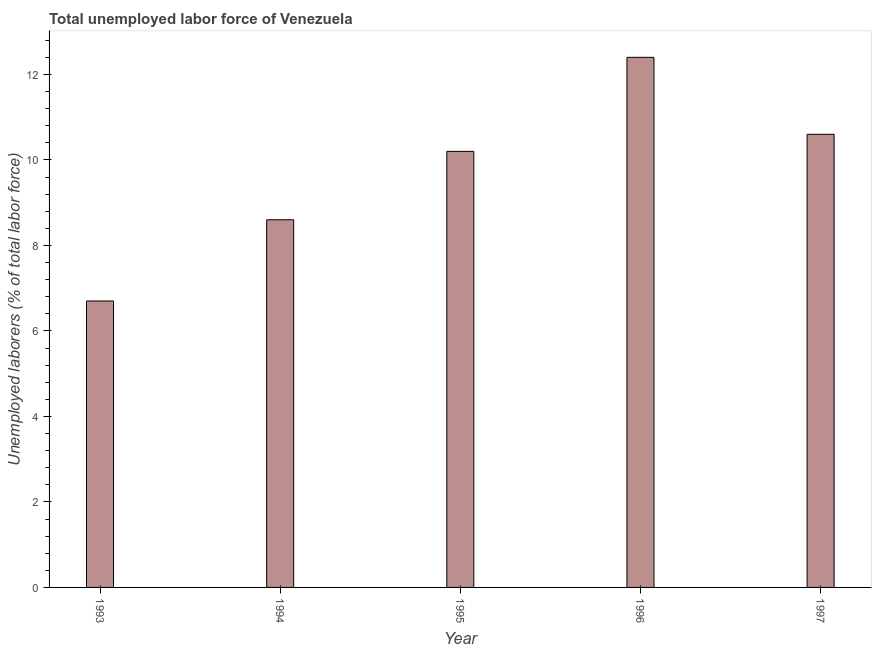What is the title of the graph?
Provide a succinct answer. Total unemployed labor force of Venezuela. What is the label or title of the X-axis?
Ensure brevity in your answer.  Year. What is the label or title of the Y-axis?
Offer a terse response. Unemployed laborers (% of total labor force). What is the total unemployed labour force in 1997?
Your answer should be very brief. 10.6. Across all years, what is the maximum total unemployed labour force?
Your response must be concise. 12.4. Across all years, what is the minimum total unemployed labour force?
Keep it short and to the point. 6.7. In which year was the total unemployed labour force maximum?
Provide a succinct answer. 1996. In which year was the total unemployed labour force minimum?
Make the answer very short. 1993. What is the sum of the total unemployed labour force?
Offer a terse response. 48.5. What is the average total unemployed labour force per year?
Ensure brevity in your answer.  9.7. What is the median total unemployed labour force?
Offer a very short reply. 10.2. Do a majority of the years between 1993 and 1997 (inclusive) have total unemployed labour force greater than 11.2 %?
Your response must be concise. No. What is the ratio of the total unemployed labour force in 1996 to that in 1997?
Ensure brevity in your answer.  1.17. Is the total unemployed labour force in 1993 less than that in 1994?
Offer a very short reply. Yes. Is the sum of the total unemployed labour force in 1993 and 1995 greater than the maximum total unemployed labour force across all years?
Your answer should be very brief. Yes. What is the difference between two consecutive major ticks on the Y-axis?
Give a very brief answer. 2. Are the values on the major ticks of Y-axis written in scientific E-notation?
Your response must be concise. No. What is the Unemployed laborers (% of total labor force) of 1993?
Ensure brevity in your answer.  6.7. What is the Unemployed laborers (% of total labor force) in 1994?
Your answer should be compact. 8.6. What is the Unemployed laborers (% of total labor force) in 1995?
Provide a short and direct response. 10.2. What is the Unemployed laborers (% of total labor force) of 1996?
Offer a very short reply. 12.4. What is the Unemployed laborers (% of total labor force) of 1997?
Make the answer very short. 10.6. What is the difference between the Unemployed laborers (% of total labor force) in 1993 and 1994?
Provide a succinct answer. -1.9. What is the difference between the Unemployed laborers (% of total labor force) in 1993 and 1995?
Provide a succinct answer. -3.5. What is the difference between the Unemployed laborers (% of total labor force) in 1993 and 1997?
Your answer should be very brief. -3.9. What is the difference between the Unemployed laborers (% of total labor force) in 1994 and 1995?
Offer a very short reply. -1.6. What is the difference between the Unemployed laborers (% of total labor force) in 1994 and 1996?
Give a very brief answer. -3.8. What is the difference between the Unemployed laborers (% of total labor force) in 1996 and 1997?
Keep it short and to the point. 1.8. What is the ratio of the Unemployed laborers (% of total labor force) in 1993 to that in 1994?
Give a very brief answer. 0.78. What is the ratio of the Unemployed laborers (% of total labor force) in 1993 to that in 1995?
Make the answer very short. 0.66. What is the ratio of the Unemployed laborers (% of total labor force) in 1993 to that in 1996?
Your answer should be compact. 0.54. What is the ratio of the Unemployed laborers (% of total labor force) in 1993 to that in 1997?
Ensure brevity in your answer.  0.63. What is the ratio of the Unemployed laborers (% of total labor force) in 1994 to that in 1995?
Provide a succinct answer. 0.84. What is the ratio of the Unemployed laborers (% of total labor force) in 1994 to that in 1996?
Your answer should be compact. 0.69. What is the ratio of the Unemployed laborers (% of total labor force) in 1994 to that in 1997?
Make the answer very short. 0.81. What is the ratio of the Unemployed laborers (% of total labor force) in 1995 to that in 1996?
Make the answer very short. 0.82. What is the ratio of the Unemployed laborers (% of total labor force) in 1995 to that in 1997?
Offer a terse response. 0.96. What is the ratio of the Unemployed laborers (% of total labor force) in 1996 to that in 1997?
Provide a succinct answer. 1.17. 